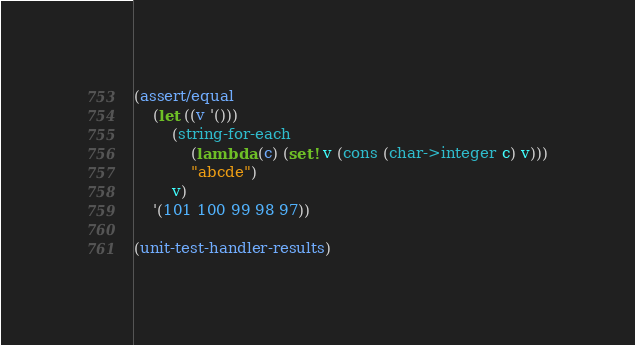<code> <loc_0><loc_0><loc_500><loc_500><_Scheme_>(assert/equal
    (let ((v '()))
        (string-for-each
            (lambda (c) (set! v (cons (char->integer c) v)))
            "abcde")
        v)
    '(101 100 99 98 97))

(unit-test-handler-results)
</code> 